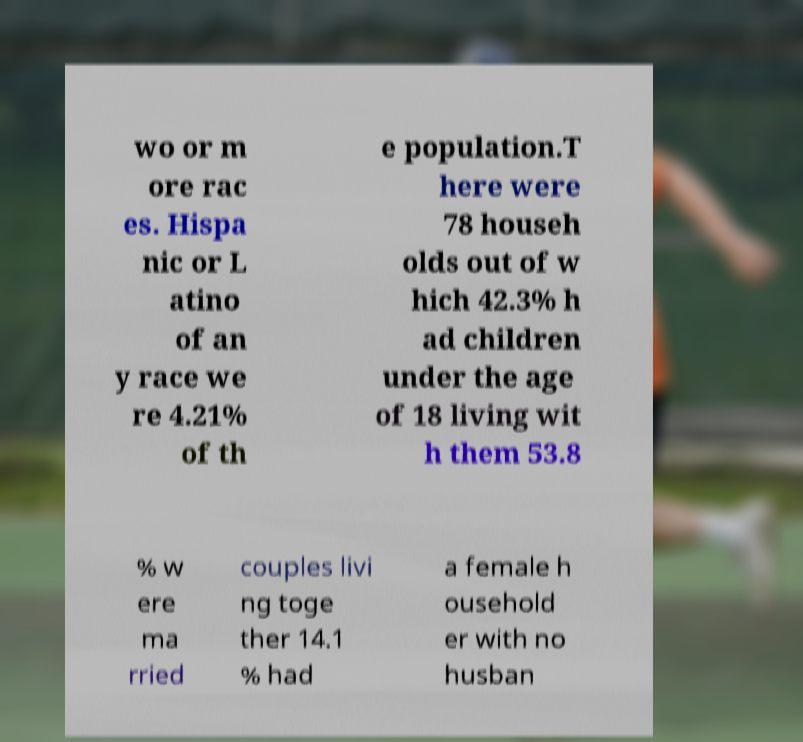For documentation purposes, I need the text within this image transcribed. Could you provide that? wo or m ore rac es. Hispa nic or L atino of an y race we re 4.21% of th e population.T here were 78 househ olds out of w hich 42.3% h ad children under the age of 18 living wit h them 53.8 % w ere ma rried couples livi ng toge ther 14.1 % had a female h ousehold er with no husban 